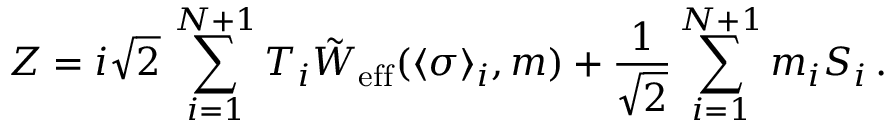<formula> <loc_0><loc_0><loc_500><loc_500>Z = i \sqrt { 2 } \, \sum _ { i = 1 } ^ { N + 1 } T _ { i } \tilde { W } _ { e f f } ( \langle \sigma \rangle _ { i } , m ) + { \frac { 1 } { \sqrt { 2 } } } \sum _ { i = 1 } ^ { N + 1 } m _ { i } S _ { i } \, .</formula> 